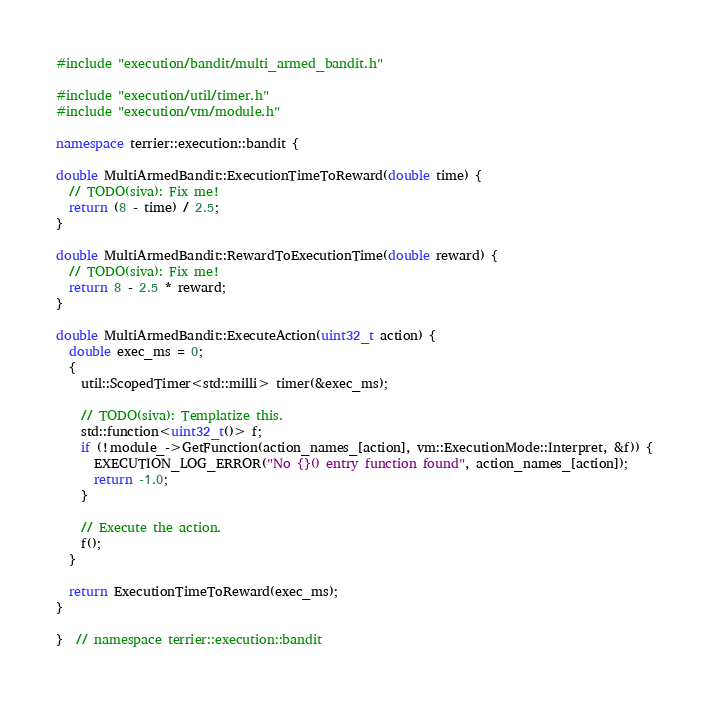Convert code to text. <code><loc_0><loc_0><loc_500><loc_500><_C++_>#include "execution/bandit/multi_armed_bandit.h"

#include "execution/util/timer.h"
#include "execution/vm/module.h"

namespace terrier::execution::bandit {

double MultiArmedBandit::ExecutionTimeToReward(double time) {
  // TODO(siva): Fix me!
  return (8 - time) / 2.5;
}

double MultiArmedBandit::RewardToExecutionTime(double reward) {
  // TODO(siva): Fix me!
  return 8 - 2.5 * reward;
}

double MultiArmedBandit::ExecuteAction(uint32_t action) {
  double exec_ms = 0;
  {
    util::ScopedTimer<std::milli> timer(&exec_ms);

    // TODO(siva): Templatize this.
    std::function<uint32_t()> f;
    if (!module_->GetFunction(action_names_[action], vm::ExecutionMode::Interpret, &f)) {
      EXECUTION_LOG_ERROR("No {}() entry function found", action_names_[action]);
      return -1.0;
    }

    // Execute the action.
    f();
  }

  return ExecutionTimeToReward(exec_ms);
}

}  // namespace terrier::execution::bandit
</code> 